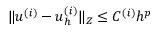<formula> <loc_0><loc_0><loc_500><loc_500>\| u ^ { ( i ) } - u _ { h } ^ { ( i ) } \| _ { Z } \leq C ^ { ( i ) } h ^ { p }</formula> 